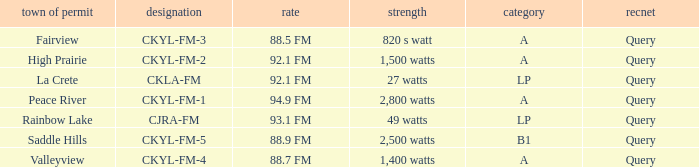What frequency is licensed in the city of fairview? 88.5 FM. 